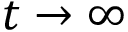<formula> <loc_0><loc_0><loc_500><loc_500>t \to \infty</formula> 